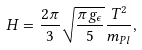<formula> <loc_0><loc_0><loc_500><loc_500>H = \frac { 2 \pi } { 3 } \sqrt { \frac { \pi g _ { \epsilon } } { 5 } } \frac { T ^ { 2 } } { m _ { P l } } ,</formula> 